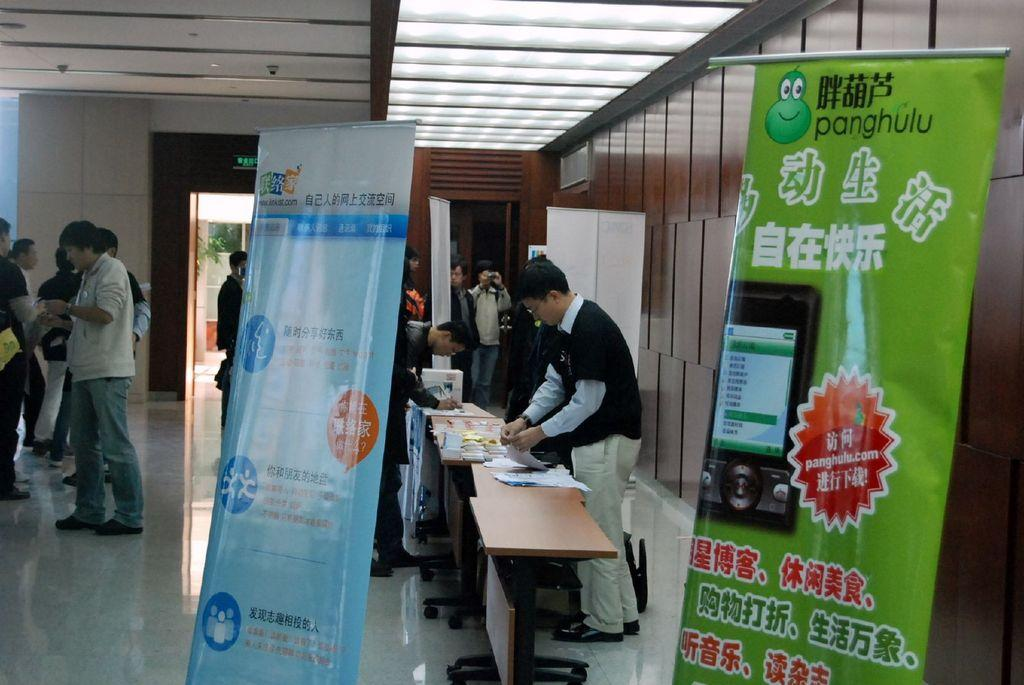What type of furniture is present in the room? There are tables in the room. What are the men in the room doing? The men are standing around the tables. Are there any decorations or signs in the room? Yes, there are two banners in the room. What type of soda is being served at the tables in the room? There is no mention of soda or any beverages in the provided facts, so it cannot be determined from the image. Are the men in the room sleeping or resting? The provided facts do not mention any men sleeping or resting; they are standing around the tables. 